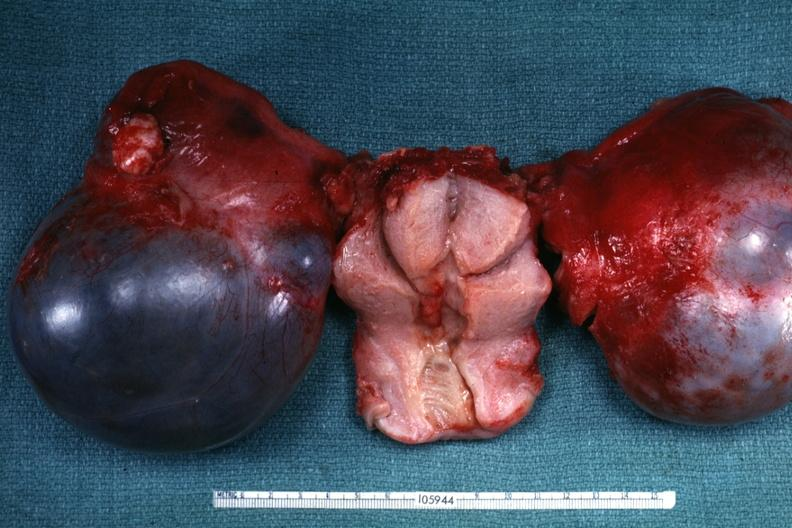s retroperitoneal liposarcoma present?
Answer the question using a single word or phrase. No 